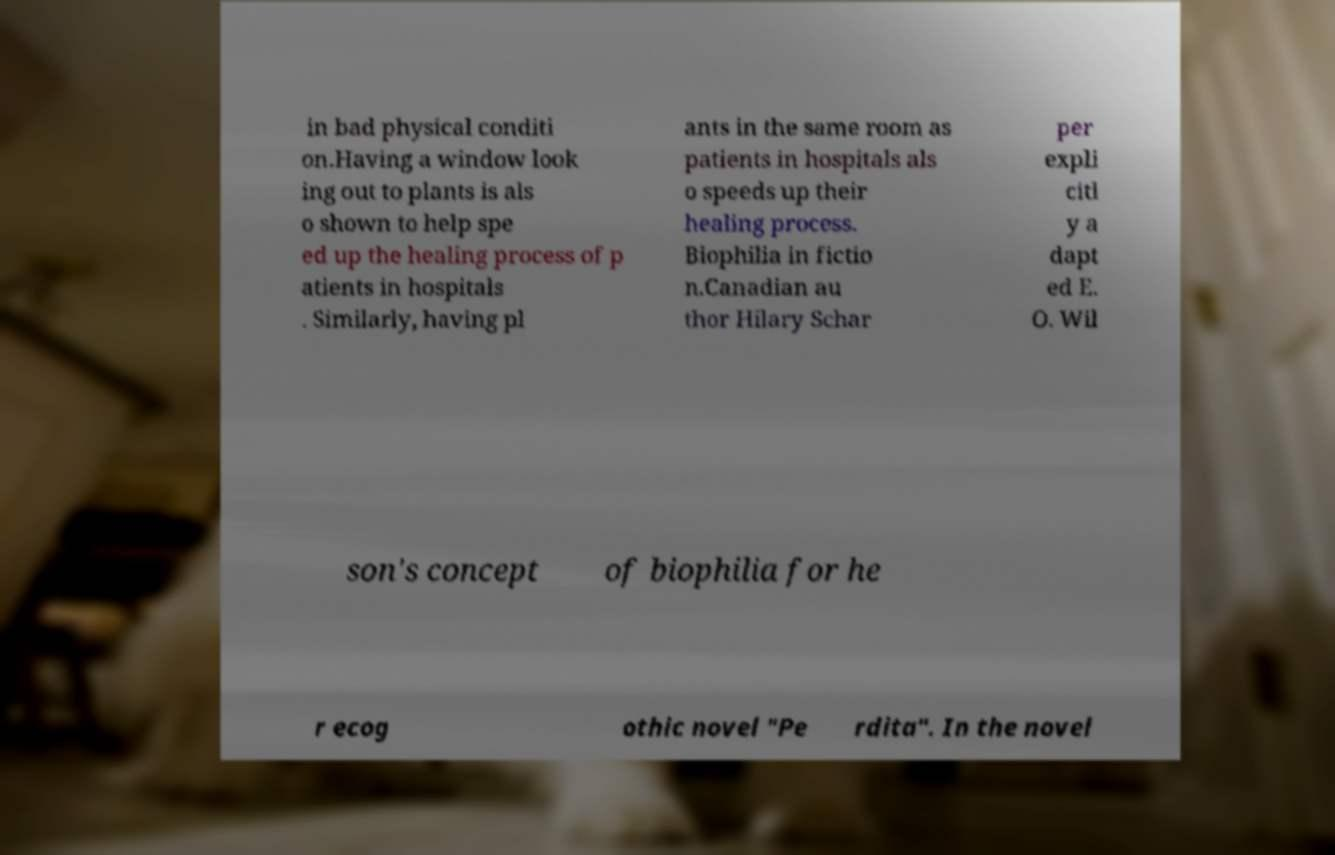Can you accurately transcribe the text from the provided image for me? in bad physical conditi on.Having a window look ing out to plants is als o shown to help spe ed up the healing process of p atients in hospitals . Similarly, having pl ants in the same room as patients in hospitals als o speeds up their healing process. Biophilia in fictio n.Canadian au thor Hilary Schar per expli citl y a dapt ed E. O. Wil son's concept of biophilia for he r ecog othic novel "Pe rdita". In the novel 